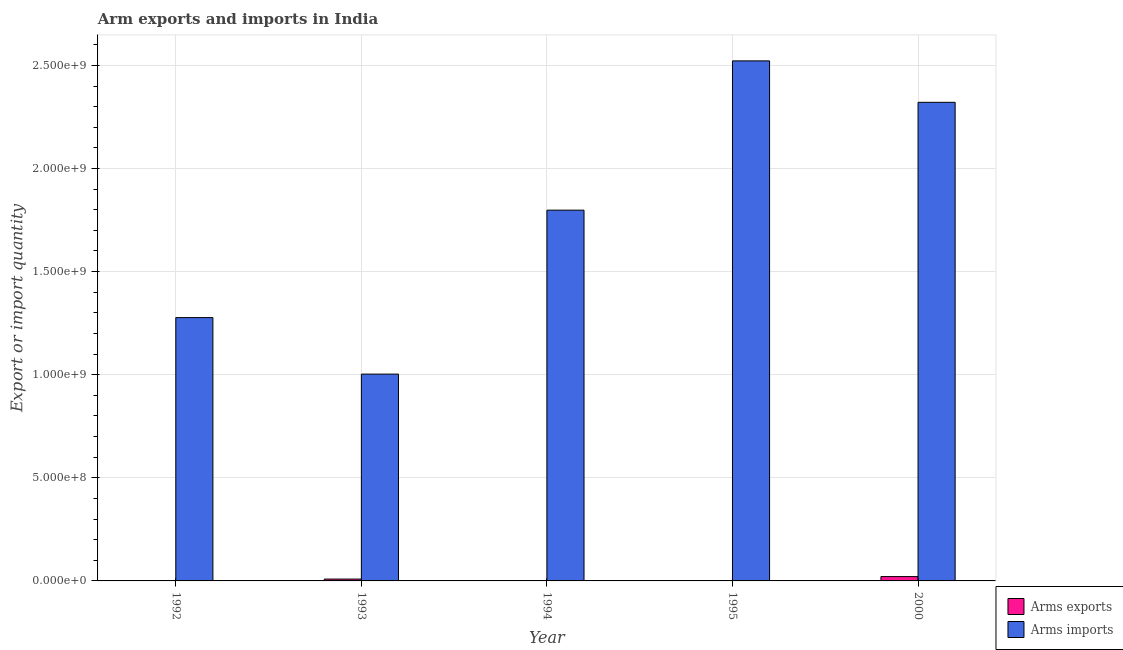How many different coloured bars are there?
Provide a short and direct response. 2. Are the number of bars per tick equal to the number of legend labels?
Provide a succinct answer. Yes. What is the arms imports in 1995?
Your response must be concise. 2.52e+09. Across all years, what is the maximum arms imports?
Provide a succinct answer. 2.52e+09. Across all years, what is the minimum arms exports?
Your answer should be very brief. 1.00e+06. In which year was the arms imports maximum?
Provide a short and direct response. 1995. What is the total arms exports in the graph?
Your answer should be very brief. 3.50e+07. What is the difference between the arms imports in 1994 and that in 1995?
Give a very brief answer. -7.24e+08. What is the difference between the arms imports in 2000 and the arms exports in 1995?
Your response must be concise. -2.01e+08. What is the average arms imports per year?
Offer a terse response. 1.78e+09. In how many years, is the arms exports greater than 1900000000?
Your answer should be compact. 0. What is the ratio of the arms exports in 1994 to that in 2000?
Your answer should be compact. 0.1. Is the arms imports in 1993 less than that in 1995?
Offer a terse response. Yes. What is the difference between the highest and the lowest arms imports?
Your answer should be compact. 1.52e+09. In how many years, is the arms imports greater than the average arms imports taken over all years?
Keep it short and to the point. 3. What does the 2nd bar from the left in 1992 represents?
Your answer should be very brief. Arms imports. What does the 2nd bar from the right in 1993 represents?
Ensure brevity in your answer.  Arms exports. How many bars are there?
Ensure brevity in your answer.  10. Does the graph contain grids?
Your answer should be compact. Yes. Where does the legend appear in the graph?
Keep it short and to the point. Bottom right. How many legend labels are there?
Your answer should be very brief. 2. How are the legend labels stacked?
Make the answer very short. Vertical. What is the title of the graph?
Your answer should be compact. Arm exports and imports in India. Does "Diarrhea" appear as one of the legend labels in the graph?
Make the answer very short. No. What is the label or title of the Y-axis?
Your answer should be compact. Export or import quantity. What is the Export or import quantity of Arms imports in 1992?
Provide a succinct answer. 1.28e+09. What is the Export or import quantity of Arms exports in 1993?
Provide a succinct answer. 9.00e+06. What is the Export or import quantity of Arms imports in 1993?
Offer a very short reply. 1.00e+09. What is the Export or import quantity in Arms imports in 1994?
Your response must be concise. 1.80e+09. What is the Export or import quantity in Arms imports in 1995?
Your answer should be compact. 2.52e+09. What is the Export or import quantity of Arms exports in 2000?
Provide a succinct answer. 2.10e+07. What is the Export or import quantity of Arms imports in 2000?
Make the answer very short. 2.32e+09. Across all years, what is the maximum Export or import quantity in Arms exports?
Ensure brevity in your answer.  2.10e+07. Across all years, what is the maximum Export or import quantity in Arms imports?
Offer a very short reply. 2.52e+09. Across all years, what is the minimum Export or import quantity in Arms imports?
Offer a very short reply. 1.00e+09. What is the total Export or import quantity of Arms exports in the graph?
Your answer should be very brief. 3.50e+07. What is the total Export or import quantity in Arms imports in the graph?
Your answer should be compact. 8.92e+09. What is the difference between the Export or import quantity in Arms exports in 1992 and that in 1993?
Make the answer very short. -8.00e+06. What is the difference between the Export or import quantity in Arms imports in 1992 and that in 1993?
Your answer should be very brief. 2.74e+08. What is the difference between the Export or import quantity of Arms exports in 1992 and that in 1994?
Your response must be concise. -1.00e+06. What is the difference between the Export or import quantity in Arms imports in 1992 and that in 1994?
Provide a short and direct response. -5.21e+08. What is the difference between the Export or import quantity in Arms imports in 1992 and that in 1995?
Offer a terse response. -1.24e+09. What is the difference between the Export or import quantity in Arms exports in 1992 and that in 2000?
Ensure brevity in your answer.  -2.00e+07. What is the difference between the Export or import quantity in Arms imports in 1992 and that in 2000?
Provide a succinct answer. -1.04e+09. What is the difference between the Export or import quantity in Arms exports in 1993 and that in 1994?
Make the answer very short. 7.00e+06. What is the difference between the Export or import quantity in Arms imports in 1993 and that in 1994?
Keep it short and to the point. -7.95e+08. What is the difference between the Export or import quantity in Arms exports in 1993 and that in 1995?
Provide a short and direct response. 7.00e+06. What is the difference between the Export or import quantity in Arms imports in 1993 and that in 1995?
Keep it short and to the point. -1.52e+09. What is the difference between the Export or import quantity in Arms exports in 1993 and that in 2000?
Give a very brief answer. -1.20e+07. What is the difference between the Export or import quantity of Arms imports in 1993 and that in 2000?
Offer a very short reply. -1.32e+09. What is the difference between the Export or import quantity of Arms imports in 1994 and that in 1995?
Provide a short and direct response. -7.24e+08. What is the difference between the Export or import quantity of Arms exports in 1994 and that in 2000?
Your answer should be compact. -1.90e+07. What is the difference between the Export or import quantity in Arms imports in 1994 and that in 2000?
Keep it short and to the point. -5.23e+08. What is the difference between the Export or import quantity in Arms exports in 1995 and that in 2000?
Your answer should be very brief. -1.90e+07. What is the difference between the Export or import quantity of Arms imports in 1995 and that in 2000?
Make the answer very short. 2.01e+08. What is the difference between the Export or import quantity of Arms exports in 1992 and the Export or import quantity of Arms imports in 1993?
Offer a very short reply. -1.00e+09. What is the difference between the Export or import quantity in Arms exports in 1992 and the Export or import quantity in Arms imports in 1994?
Your response must be concise. -1.80e+09. What is the difference between the Export or import quantity in Arms exports in 1992 and the Export or import quantity in Arms imports in 1995?
Provide a succinct answer. -2.52e+09. What is the difference between the Export or import quantity of Arms exports in 1992 and the Export or import quantity of Arms imports in 2000?
Provide a succinct answer. -2.32e+09. What is the difference between the Export or import quantity in Arms exports in 1993 and the Export or import quantity in Arms imports in 1994?
Make the answer very short. -1.79e+09. What is the difference between the Export or import quantity of Arms exports in 1993 and the Export or import quantity of Arms imports in 1995?
Ensure brevity in your answer.  -2.51e+09. What is the difference between the Export or import quantity of Arms exports in 1993 and the Export or import quantity of Arms imports in 2000?
Make the answer very short. -2.31e+09. What is the difference between the Export or import quantity of Arms exports in 1994 and the Export or import quantity of Arms imports in 1995?
Give a very brief answer. -2.52e+09. What is the difference between the Export or import quantity in Arms exports in 1994 and the Export or import quantity in Arms imports in 2000?
Offer a terse response. -2.32e+09. What is the difference between the Export or import quantity of Arms exports in 1995 and the Export or import quantity of Arms imports in 2000?
Your answer should be very brief. -2.32e+09. What is the average Export or import quantity of Arms exports per year?
Your response must be concise. 7.00e+06. What is the average Export or import quantity of Arms imports per year?
Make the answer very short. 1.78e+09. In the year 1992, what is the difference between the Export or import quantity of Arms exports and Export or import quantity of Arms imports?
Keep it short and to the point. -1.28e+09. In the year 1993, what is the difference between the Export or import quantity in Arms exports and Export or import quantity in Arms imports?
Make the answer very short. -9.94e+08. In the year 1994, what is the difference between the Export or import quantity in Arms exports and Export or import quantity in Arms imports?
Your response must be concise. -1.80e+09. In the year 1995, what is the difference between the Export or import quantity of Arms exports and Export or import quantity of Arms imports?
Give a very brief answer. -2.52e+09. In the year 2000, what is the difference between the Export or import quantity of Arms exports and Export or import quantity of Arms imports?
Your answer should be compact. -2.30e+09. What is the ratio of the Export or import quantity of Arms imports in 1992 to that in 1993?
Offer a terse response. 1.27. What is the ratio of the Export or import quantity in Arms exports in 1992 to that in 1994?
Keep it short and to the point. 0.5. What is the ratio of the Export or import quantity in Arms imports in 1992 to that in 1994?
Offer a terse response. 0.71. What is the ratio of the Export or import quantity of Arms imports in 1992 to that in 1995?
Provide a short and direct response. 0.51. What is the ratio of the Export or import quantity of Arms exports in 1992 to that in 2000?
Keep it short and to the point. 0.05. What is the ratio of the Export or import quantity in Arms imports in 1992 to that in 2000?
Keep it short and to the point. 0.55. What is the ratio of the Export or import quantity in Arms imports in 1993 to that in 1994?
Give a very brief answer. 0.56. What is the ratio of the Export or import quantity in Arms exports in 1993 to that in 1995?
Provide a short and direct response. 4.5. What is the ratio of the Export or import quantity of Arms imports in 1993 to that in 1995?
Your answer should be very brief. 0.4. What is the ratio of the Export or import quantity in Arms exports in 1993 to that in 2000?
Give a very brief answer. 0.43. What is the ratio of the Export or import quantity in Arms imports in 1993 to that in 2000?
Provide a succinct answer. 0.43. What is the ratio of the Export or import quantity of Arms exports in 1994 to that in 1995?
Your answer should be compact. 1. What is the ratio of the Export or import quantity in Arms imports in 1994 to that in 1995?
Make the answer very short. 0.71. What is the ratio of the Export or import quantity in Arms exports in 1994 to that in 2000?
Your answer should be compact. 0.1. What is the ratio of the Export or import quantity in Arms imports in 1994 to that in 2000?
Ensure brevity in your answer.  0.77. What is the ratio of the Export or import quantity of Arms exports in 1995 to that in 2000?
Offer a terse response. 0.1. What is the ratio of the Export or import quantity of Arms imports in 1995 to that in 2000?
Make the answer very short. 1.09. What is the difference between the highest and the second highest Export or import quantity of Arms exports?
Your answer should be very brief. 1.20e+07. What is the difference between the highest and the second highest Export or import quantity in Arms imports?
Make the answer very short. 2.01e+08. What is the difference between the highest and the lowest Export or import quantity of Arms exports?
Give a very brief answer. 2.00e+07. What is the difference between the highest and the lowest Export or import quantity in Arms imports?
Provide a short and direct response. 1.52e+09. 